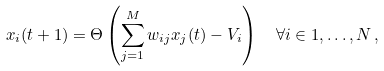<formula> <loc_0><loc_0><loc_500><loc_500>x _ { i } ( t + 1 ) & = \Theta \left ( \sum _ { j = 1 } ^ { M } w _ { i j } x _ { j } ( t ) - V _ { i } \right ) \quad \forall i \in 1 , \dots , N \, ,</formula> 